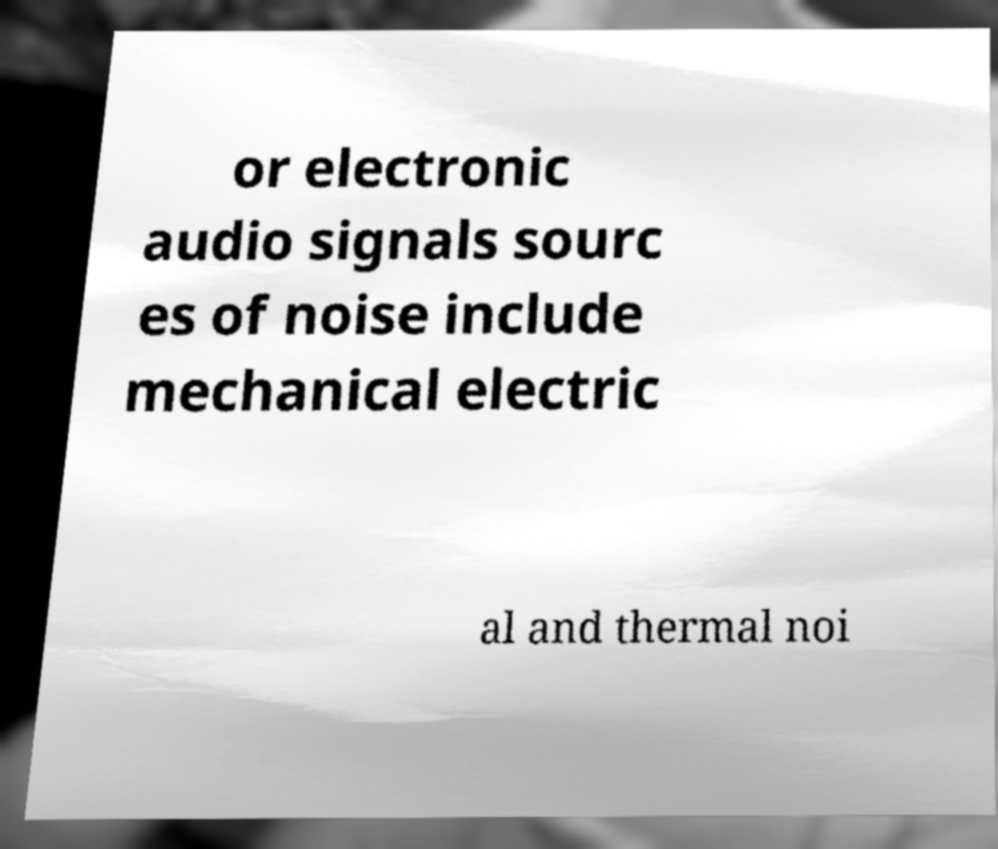Can you read and provide the text displayed in the image?This photo seems to have some interesting text. Can you extract and type it out for me? or electronic audio signals sourc es of noise include mechanical electric al and thermal noi 